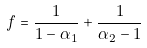<formula> <loc_0><loc_0><loc_500><loc_500>f = \frac { 1 } { 1 - \alpha _ { 1 } } + \frac { 1 } { \alpha _ { 2 } - 1 }</formula> 